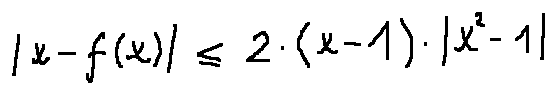<formula> <loc_0><loc_0><loc_500><loc_500>| x - f ( x ) | \leq 2 \cdot ( x - 1 ) \cdot | x ^ { 2 } - 1 |</formula> 